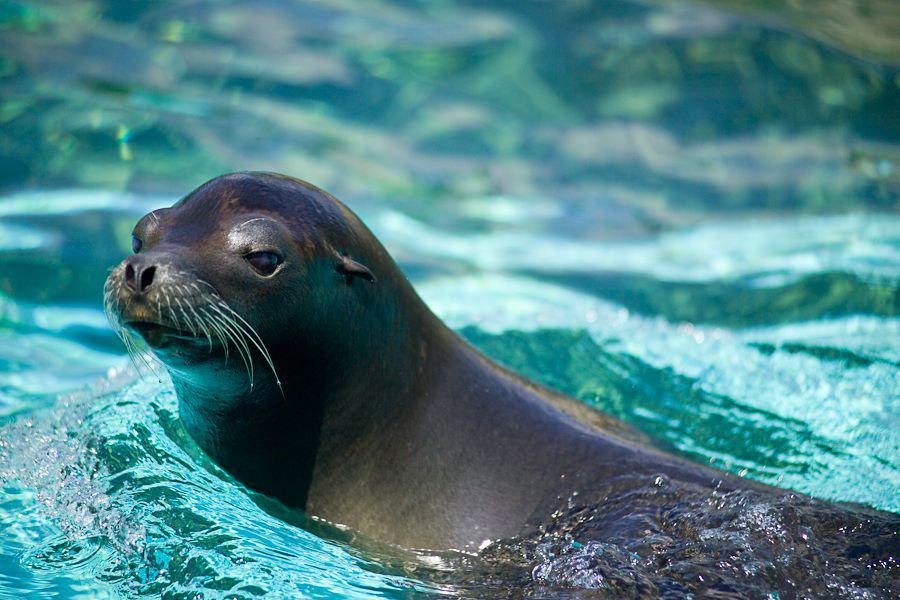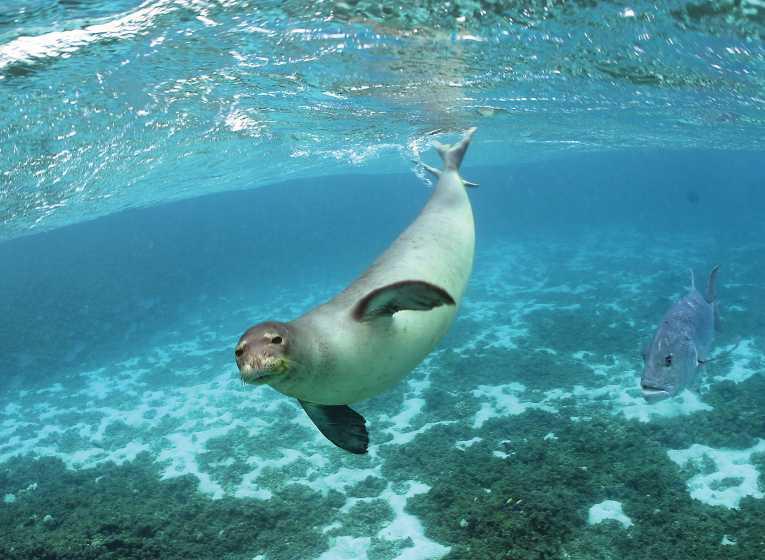The first image is the image on the left, the second image is the image on the right. Evaluate the accuracy of this statement regarding the images: "There is at least one seal resting on a solid surface". Is it true? Answer yes or no. No. 